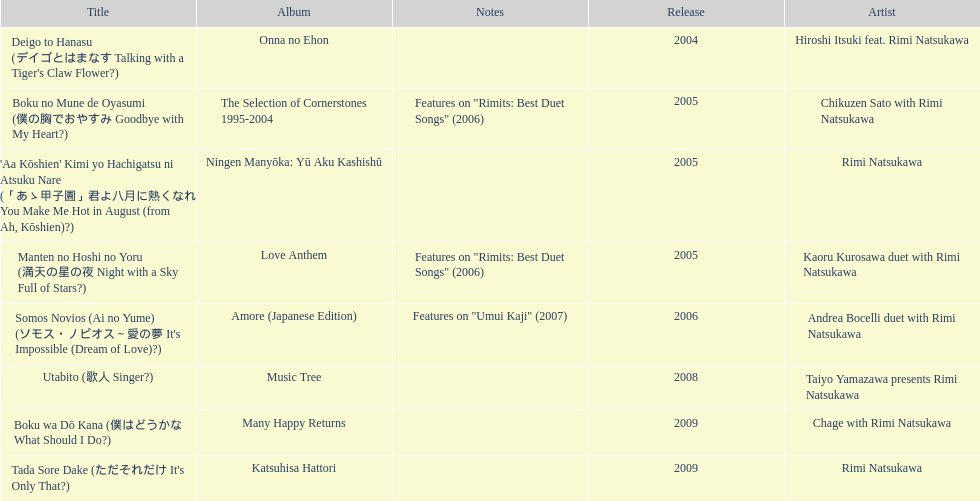How many other appearance did this artist make in 2005? 3. 